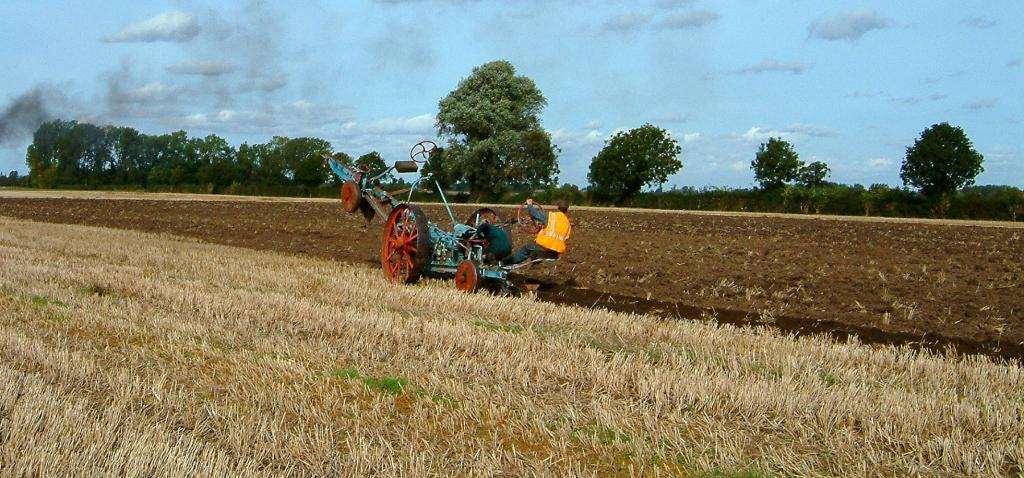What is the person in the image doing? There is a person riding a vehicle on the ground in the image. What can be seen in the background of the image? There are trees and the sky visible in the background of the image. What is the condition of the sky in the image? Clouds are present in the sky in the image. What type of meat is being served on the island in the image? There is no island or meat present in the image; it features a person riding a vehicle on the ground with trees and clouds in the background. 